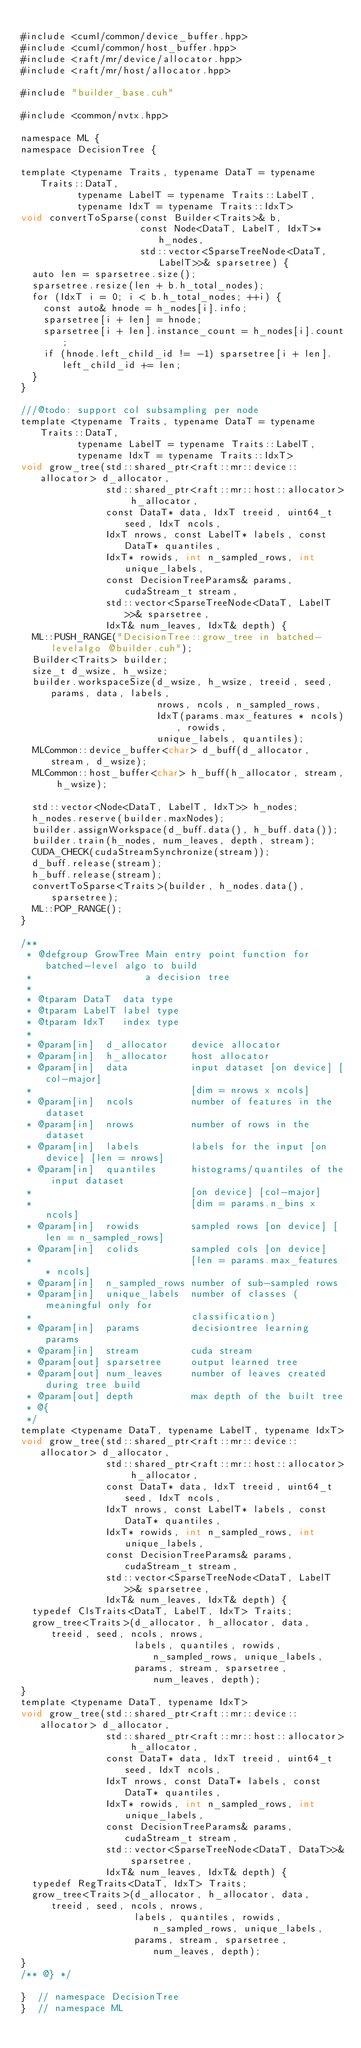<code> <loc_0><loc_0><loc_500><loc_500><_Cuda_>
#include <cuml/common/device_buffer.hpp>
#include <cuml/common/host_buffer.hpp>
#include <raft/mr/device/allocator.hpp>
#include <raft/mr/host/allocator.hpp>

#include "builder_base.cuh"

#include <common/nvtx.hpp>

namespace ML {
namespace DecisionTree {

template <typename Traits, typename DataT = typename Traits::DataT,
          typename LabelT = typename Traits::LabelT,
          typename IdxT = typename Traits::IdxT>
void convertToSparse(const Builder<Traits>& b,
                     const Node<DataT, LabelT, IdxT>* h_nodes,
                     std::vector<SparseTreeNode<DataT, LabelT>>& sparsetree) {
  auto len = sparsetree.size();
  sparsetree.resize(len + b.h_total_nodes);
  for (IdxT i = 0; i < b.h_total_nodes; ++i) {
    const auto& hnode = h_nodes[i].info;
    sparsetree[i + len] = hnode;
    sparsetree[i + len].instance_count = h_nodes[i].count;
    if (hnode.left_child_id != -1) sparsetree[i + len].left_child_id += len;
  }
}

///@todo: support col subsampling per node
template <typename Traits, typename DataT = typename Traits::DataT,
          typename LabelT = typename Traits::LabelT,
          typename IdxT = typename Traits::IdxT>
void grow_tree(std::shared_ptr<raft::mr::device::allocator> d_allocator,
               std::shared_ptr<raft::mr::host::allocator> h_allocator,
               const DataT* data, IdxT treeid, uint64_t seed, IdxT ncols,
               IdxT nrows, const LabelT* labels, const DataT* quantiles,
               IdxT* rowids, int n_sampled_rows, int unique_labels,
               const DecisionTreeParams& params, cudaStream_t stream,
               std::vector<SparseTreeNode<DataT, LabelT>>& sparsetree,
               IdxT& num_leaves, IdxT& depth) {
  ML::PUSH_RANGE("DecisionTree::grow_tree in batched-levelalgo @builder.cuh");
  Builder<Traits> builder;
  size_t d_wsize, h_wsize;
  builder.workspaceSize(d_wsize, h_wsize, treeid, seed, params, data, labels,
                        nrows, ncols, n_sampled_rows,
                        IdxT(params.max_features * ncols), rowids,
                        unique_labels, quantiles);
  MLCommon::device_buffer<char> d_buff(d_allocator, stream, d_wsize);
  MLCommon::host_buffer<char> h_buff(h_allocator, stream, h_wsize);

  std::vector<Node<DataT, LabelT, IdxT>> h_nodes;
  h_nodes.reserve(builder.maxNodes);
  builder.assignWorkspace(d_buff.data(), h_buff.data());
  builder.train(h_nodes, num_leaves, depth, stream);
  CUDA_CHECK(cudaStreamSynchronize(stream));
  d_buff.release(stream);
  h_buff.release(stream);
  convertToSparse<Traits>(builder, h_nodes.data(), sparsetree);
  ML::POP_RANGE();
}

/**
 * @defgroup GrowTree Main entry point function for batched-level algo to build
 *                    a decision tree
 *
 * @tparam DataT  data type
 * @tparam LabelT label type
 * @tparam IdxT   index type
 *
 * @param[in]  d_allocator    device allocator
 * @param[in]  h_allocator    host allocator
 * @param[in]  data           input dataset [on device] [col-major]
 *                            [dim = nrows x ncols]
 * @param[in]  ncols          number of features in the dataset
 * @param[in]  nrows          number of rows in the dataset
 * @param[in]  labels         labels for the input [on device] [len = nrows]
 * @param[in]  quantiles      histograms/quantiles of the input dataset
 *                            [on device] [col-major]
 *                            [dim = params.n_bins x ncols]
 * @param[in]  rowids         sampled rows [on device] [len = n_sampled_rows]
 * @param[in]  colids         sampled cols [on device]
 *                            [len = params.max_features * ncols]
 * @param[in]  n_sampled_rows number of sub-sampled rows
 * @param[in]  unique_labels  number of classes (meaningful only for
 *                            classification)
 * @param[in]  params         decisiontree learning params
 * @param[in]  stream         cuda stream
 * @param[out] sparsetree     output learned tree
 * @param[out] num_leaves     number of leaves created during tree build
 * @param[out] depth          max depth of the built tree
 * @{
 */
template <typename DataT, typename LabelT, typename IdxT>
void grow_tree(std::shared_ptr<raft::mr::device::allocator> d_allocator,
               std::shared_ptr<raft::mr::host::allocator> h_allocator,
               const DataT* data, IdxT treeid, uint64_t seed, IdxT ncols,
               IdxT nrows, const LabelT* labels, const DataT* quantiles,
               IdxT* rowids, int n_sampled_rows, int unique_labels,
               const DecisionTreeParams& params, cudaStream_t stream,
               std::vector<SparseTreeNode<DataT, LabelT>>& sparsetree,
               IdxT& num_leaves, IdxT& depth) {
  typedef ClsTraits<DataT, LabelT, IdxT> Traits;
  grow_tree<Traits>(d_allocator, h_allocator, data, treeid, seed, ncols, nrows,
                    labels, quantiles, rowids, n_sampled_rows, unique_labels,
                    params, stream, sparsetree, num_leaves, depth);
}
template <typename DataT, typename IdxT>
void grow_tree(std::shared_ptr<raft::mr::device::allocator> d_allocator,
               std::shared_ptr<raft::mr::host::allocator> h_allocator,
               const DataT* data, IdxT treeid, uint64_t seed, IdxT ncols,
               IdxT nrows, const DataT* labels, const DataT* quantiles,
               IdxT* rowids, int n_sampled_rows, int unique_labels,
               const DecisionTreeParams& params, cudaStream_t stream,
               std::vector<SparseTreeNode<DataT, DataT>>& sparsetree,
               IdxT& num_leaves, IdxT& depth) {
  typedef RegTraits<DataT, IdxT> Traits;
  grow_tree<Traits>(d_allocator, h_allocator, data, treeid, seed, ncols, nrows,
                    labels, quantiles, rowids, n_sampled_rows, unique_labels,
                    params, stream, sparsetree, num_leaves, depth);
}
/** @} */

}  // namespace DecisionTree
}  // namespace ML
</code> 